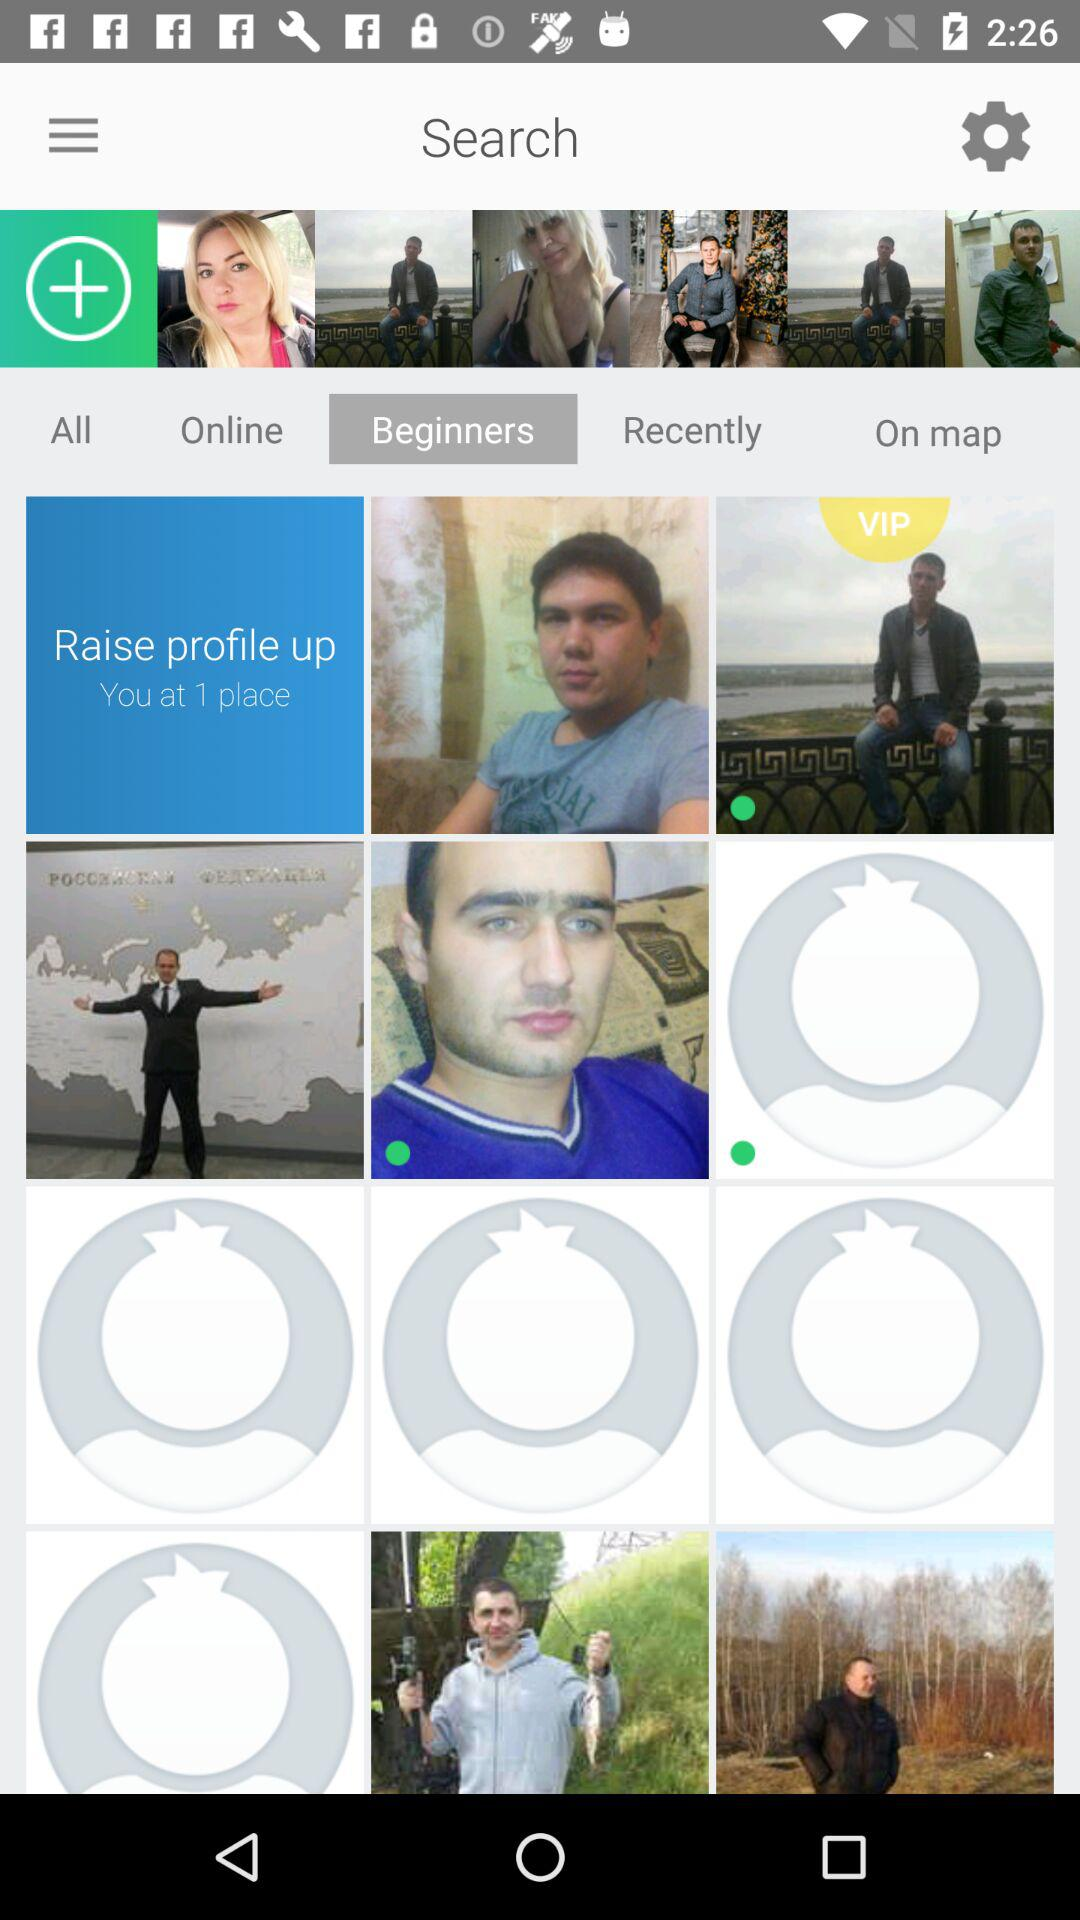Who's online?
When the provided information is insufficient, respond with <no answer>. <no answer> 